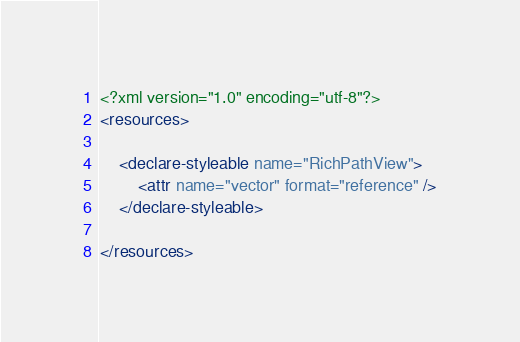Convert code to text. <code><loc_0><loc_0><loc_500><loc_500><_XML_><?xml version="1.0" encoding="utf-8"?>
<resources>

    <declare-styleable name="RichPathView">
        <attr name="vector" format="reference" />
    </declare-styleable>

</resources></code> 